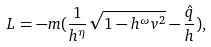Convert formula to latex. <formula><loc_0><loc_0><loc_500><loc_500>L = - m ( \frac { 1 } { h ^ { \eta } } \sqrt { 1 - h ^ { \omega } v ^ { 2 } } - \frac { \hat { q } } { h } ) ,</formula> 